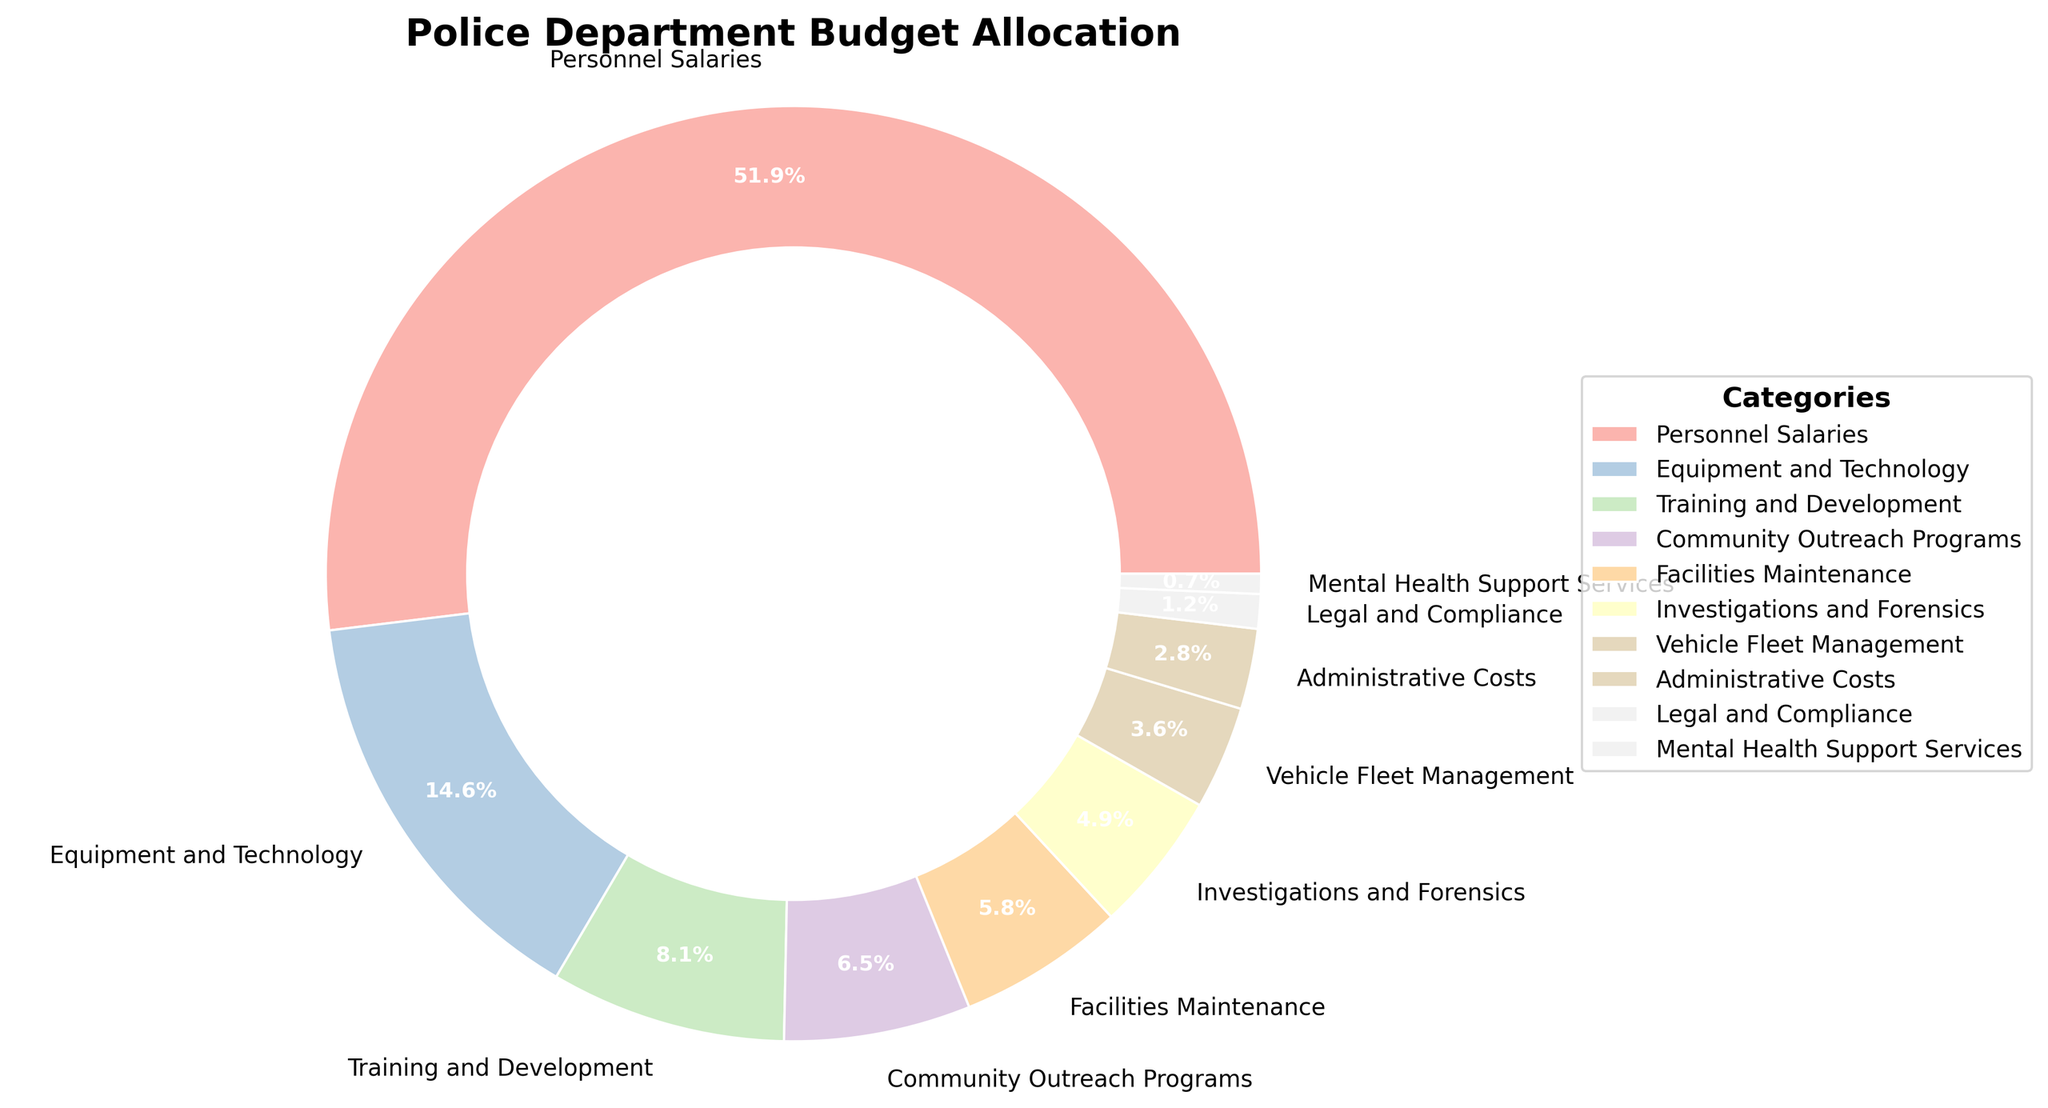which category has the highest percentage allocation? The segment labeled "Personnel Salaries" has the highest percentage, indicated at 52.3%. This can be directly seen from the pie chart where the size of the segment is largest.
Answer: Personnel Salaries What is the combined percentage allocation for Training and Development and Equipment and Technology? The figure shows Training and Development at 8.2% and Equipment and Technology at 14.7%. Adding these together (8.2 + 14.7) gives a total of 22.9%.
Answer: 22.9% Which category has a higher percentage, Community Outreach Programs or Facilities Maintenance? The figure shows that Community Outreach Programs is at 6.5% and Facilities Maintenance is at 5.8%. 6.5% is higher than 5.8%.
Answer: Community Outreach Programs Are the percentages allocated to Investigations and Forensics and Vehicle Fleet Management, combined, more than that allocated to Training and Development? Investigations and Forensics has 4.9% and Vehicle Fleet Management has 3.6%. Adding these together (4.9 + 3.6) gives 8.5%, which is more than the 8.2% allocated to Training and Development.
Answer: Yes What is the ratio of the percentage allocation to Equipment and Technology compared to Mental Health Support Services? Equipment and Technology is 14.7% and Mental Health Support Services is 0.7%. Dividing 14.7 by 0.7 gives a ratio of 21:1.
Answer: 21:1 How much more percentage allocation does Personnel Salaries have compared to the combined percentages of Administrative Costs and Legal and Compliance? Personnel Salaries has 52.3%. Administrative Costs is 2.8% and Legal and Compliance is 1.2%, combined they are 4.0% (2.8 + 1.2). Subtracting this from Personnel Salaries (52.3 - 4.0) gives 48.3%.
Answer: 48.3% Is the percentage allocated to Equipment and Technology greater than the sum of the allocations to Facilities Maintenance and Vehicle Fleet Management? Equipment and Technology is 14.7%. Facilities Maintenance is 5.8% and Vehicle Fleet Management is 3.6%, combined they are 9.4% (5.8 + 3.6). Thus, 14.7% is greater than 9.4%.
Answer: Yes What is the average percentage allocation across all categories? Adding all percentages together (52.3 + 14.7 + 8.2 + 6.5 + 5.8 + 4.9 + 3.6 + 2.8 + 1.2 + 0.7) gives a total of 100%. Since there are 10 categories, dividing 100% by 10 gives an average of 10%.
Answer: 10% What is the difference in percentage allocation between Personnel Salaries and Equipment and Technology? Personnel Salaries is 52.3% and Equipment and Technology is 14.7%. Subtracting Equipment and Technology from Personnel Salaries (52.3 - 14.7) gives a difference of 37.6%.
Answer: 37.6% 